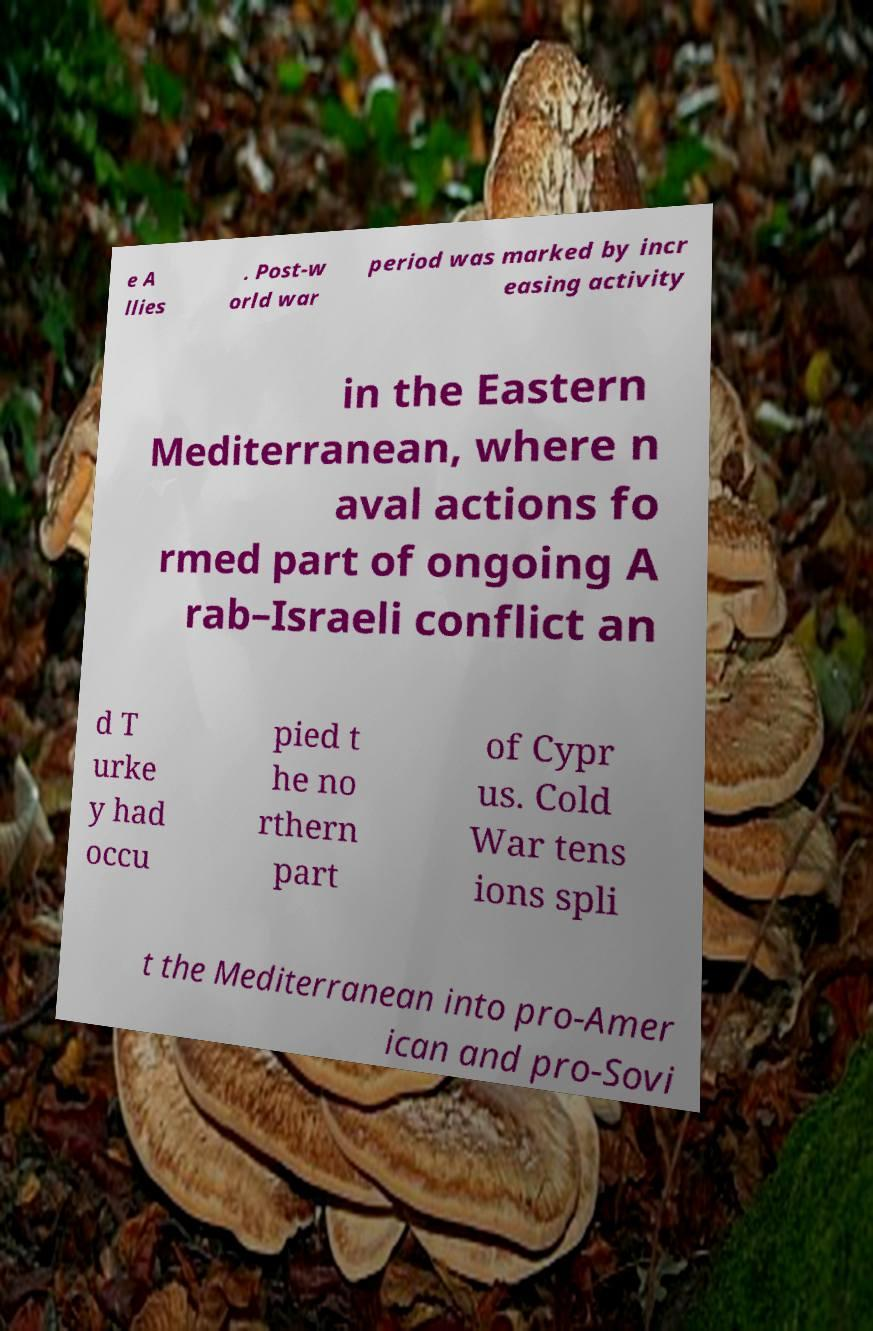Could you assist in decoding the text presented in this image and type it out clearly? e A llies . Post-w orld war period was marked by incr easing activity in the Eastern Mediterranean, where n aval actions fo rmed part of ongoing A rab–Israeli conflict an d T urke y had occu pied t he no rthern part of Cypr us. Cold War tens ions spli t the Mediterranean into pro-Amer ican and pro-Sovi 